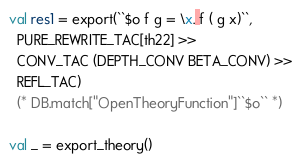<code> <loc_0><loc_0><loc_500><loc_500><_SML_>val res1 = export(``$o f g = \x. f ( g x)``,
  PURE_REWRITE_TAC[th22] >>
  CONV_TAC (DEPTH_CONV BETA_CONV) >>
  REFL_TAC)
  (* DB.match["OpenTheoryFunction"]``$o`` *)

val _ = export_theory()
</code> 